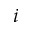Convert formula to latex. <formula><loc_0><loc_0><loc_500><loc_500>i</formula> 